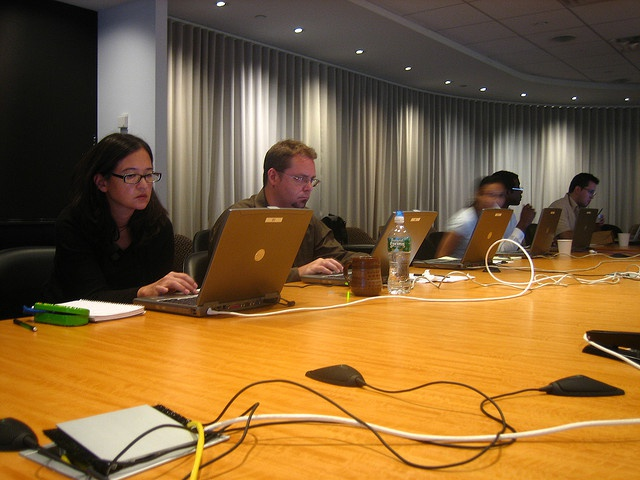Describe the objects in this image and their specific colors. I can see people in black, maroon, and brown tones, laptop in black, maroon, and brown tones, book in black, beige, and darkgray tones, people in black, maroon, and brown tones, and chair in black, darkgreen, navy, and maroon tones in this image. 